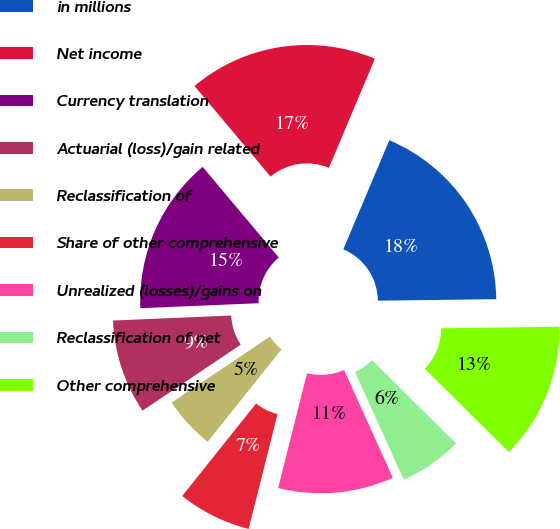Convert chart to OTSL. <chart><loc_0><loc_0><loc_500><loc_500><pie_chart><fcel>in millions<fcel>Net income<fcel>Currency translation<fcel>Actuarial (loss)/gain related<fcel>Reclassification of<fcel>Share of other comprehensive<fcel>Unrealized (losses)/gains on<fcel>Reclassification of net<fcel>Other comprehensive<nl><fcel>18.45%<fcel>17.47%<fcel>14.56%<fcel>8.74%<fcel>4.86%<fcel>6.8%<fcel>10.68%<fcel>5.83%<fcel>12.62%<nl></chart> 